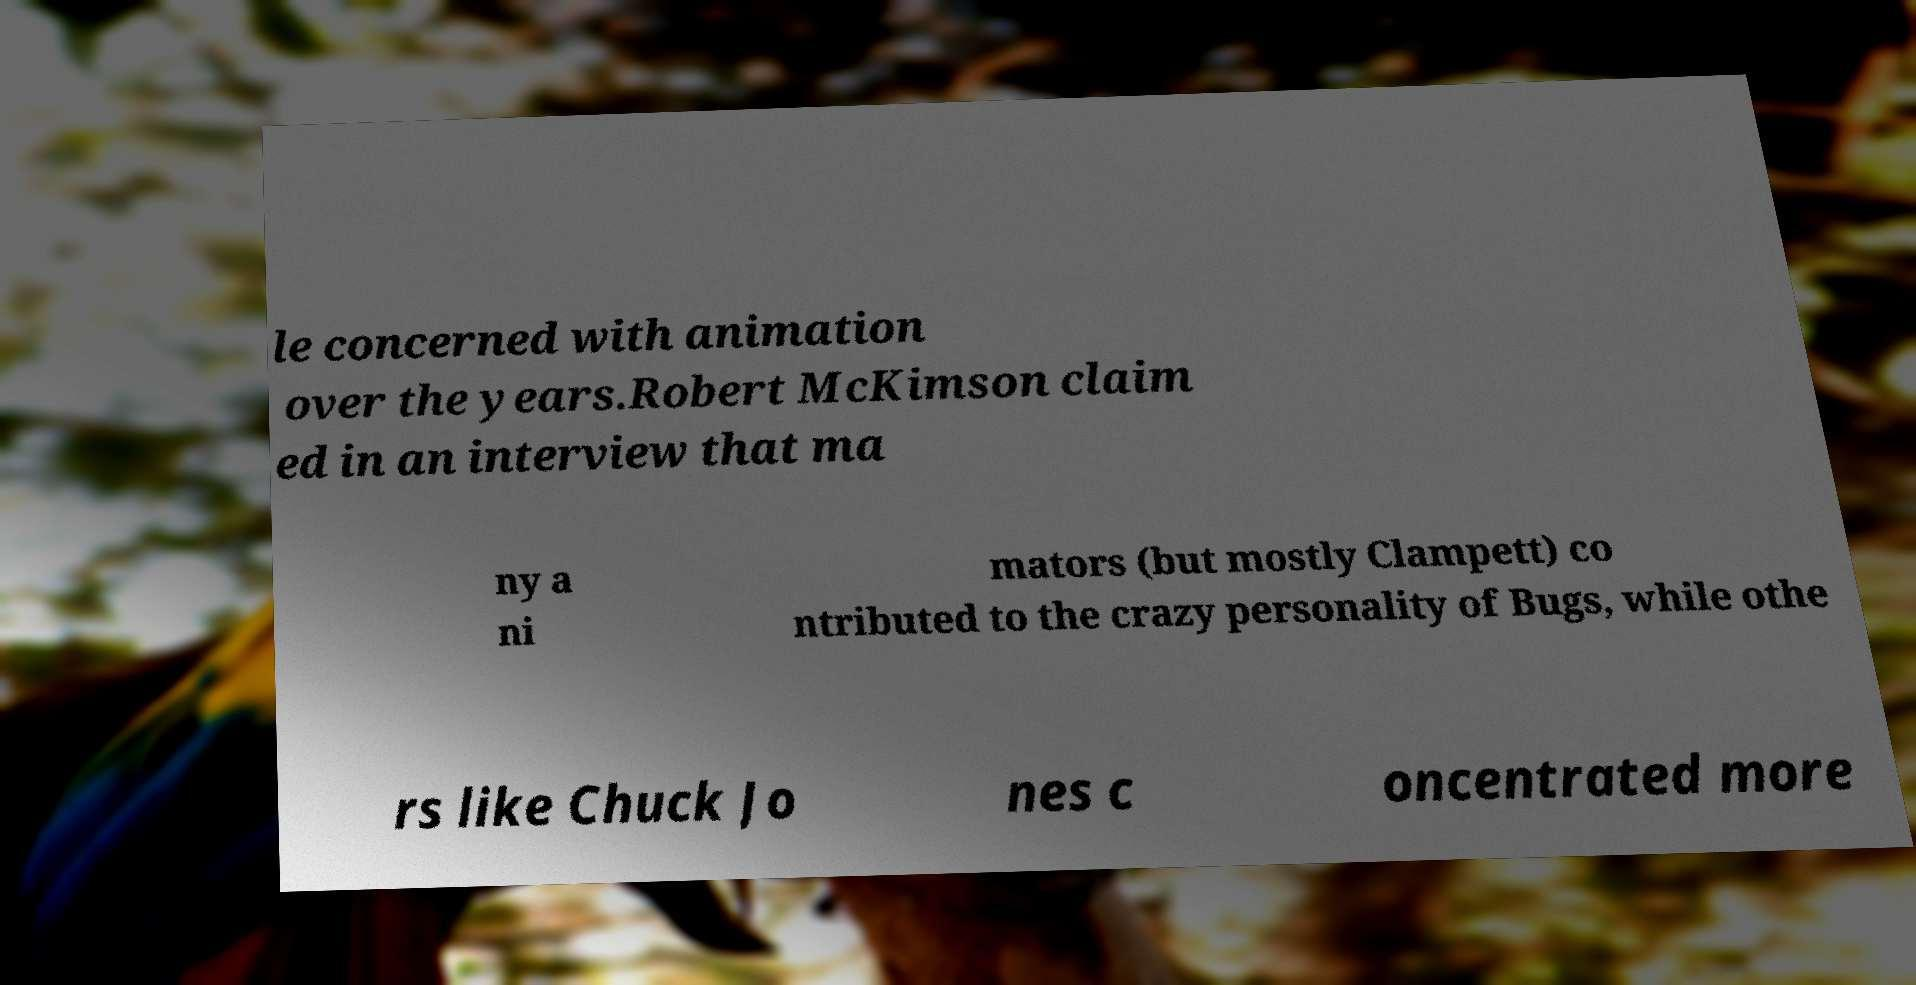What messages or text are displayed in this image? I need them in a readable, typed format. le concerned with animation over the years.Robert McKimson claim ed in an interview that ma ny a ni mators (but mostly Clampett) co ntributed to the crazy personality of Bugs, while othe rs like Chuck Jo nes c oncentrated more 